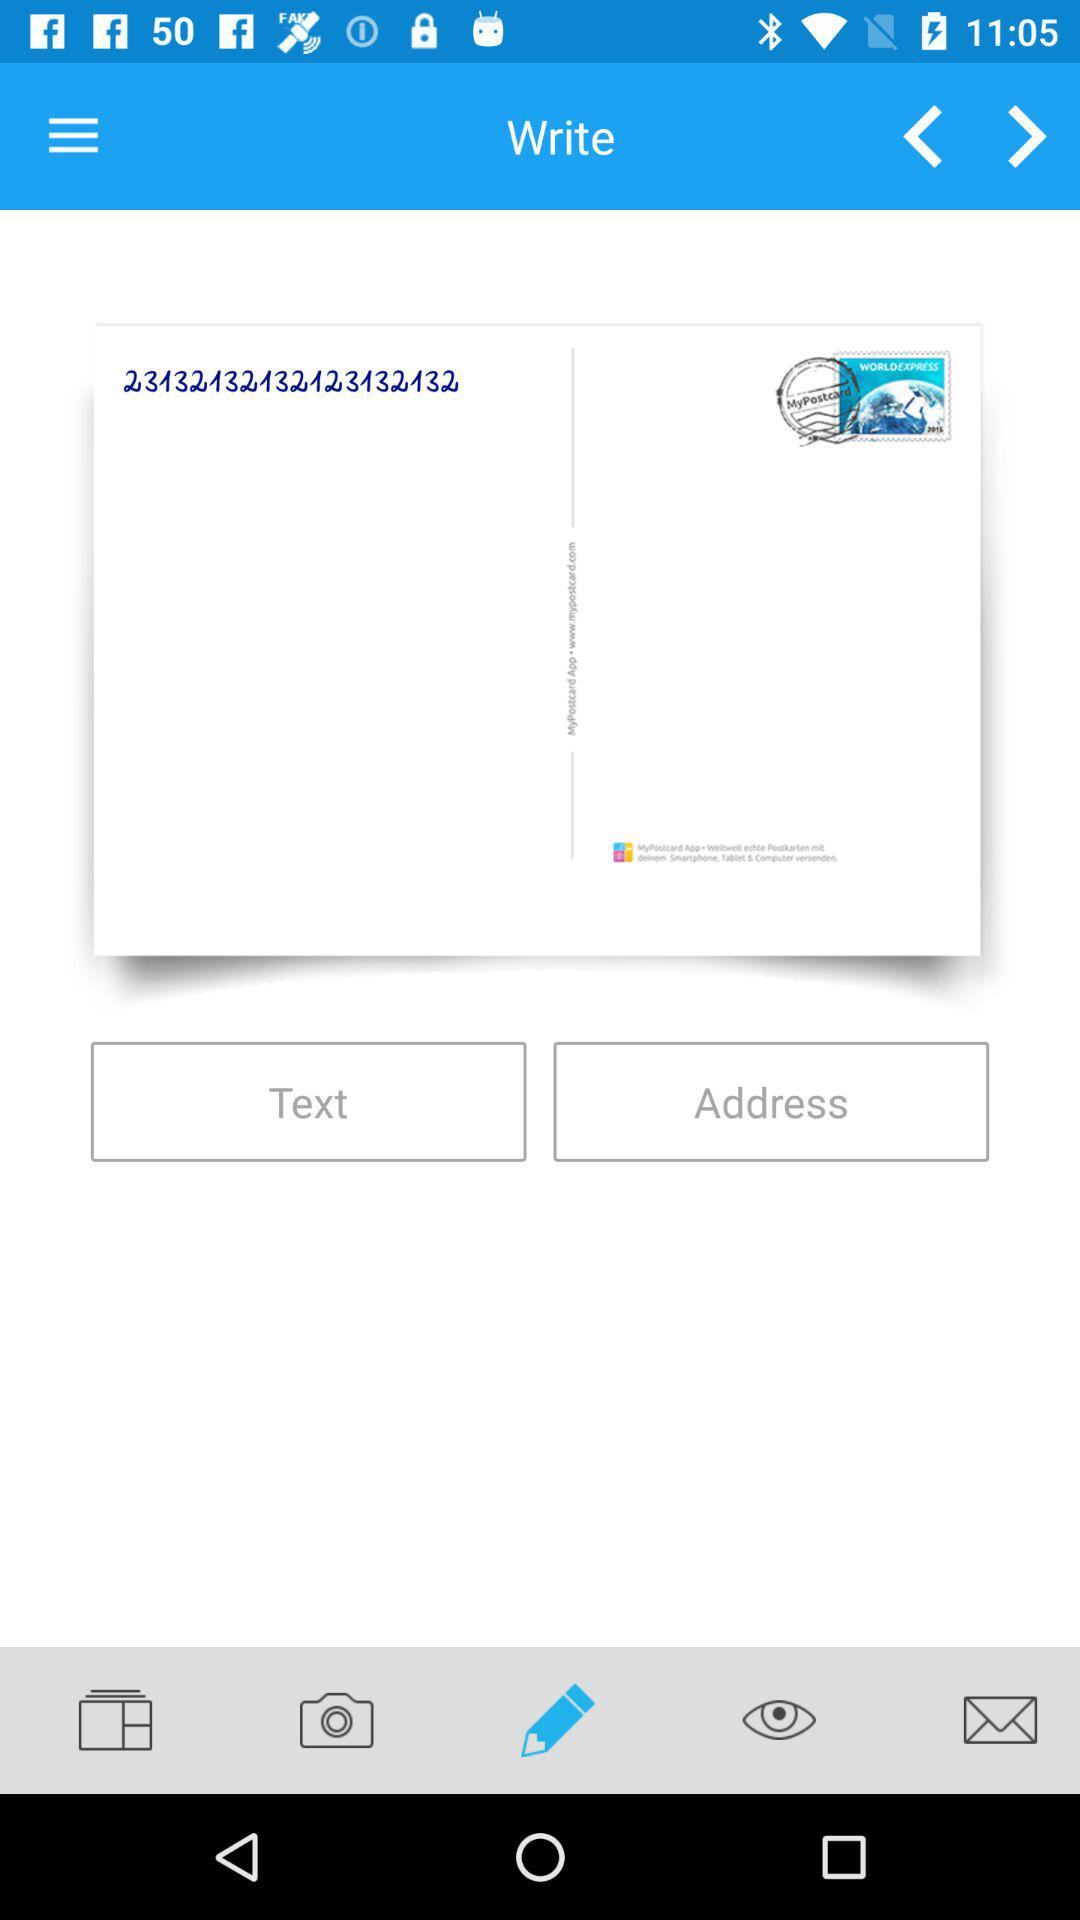Which tab is selected? The selected tab is "Write". 